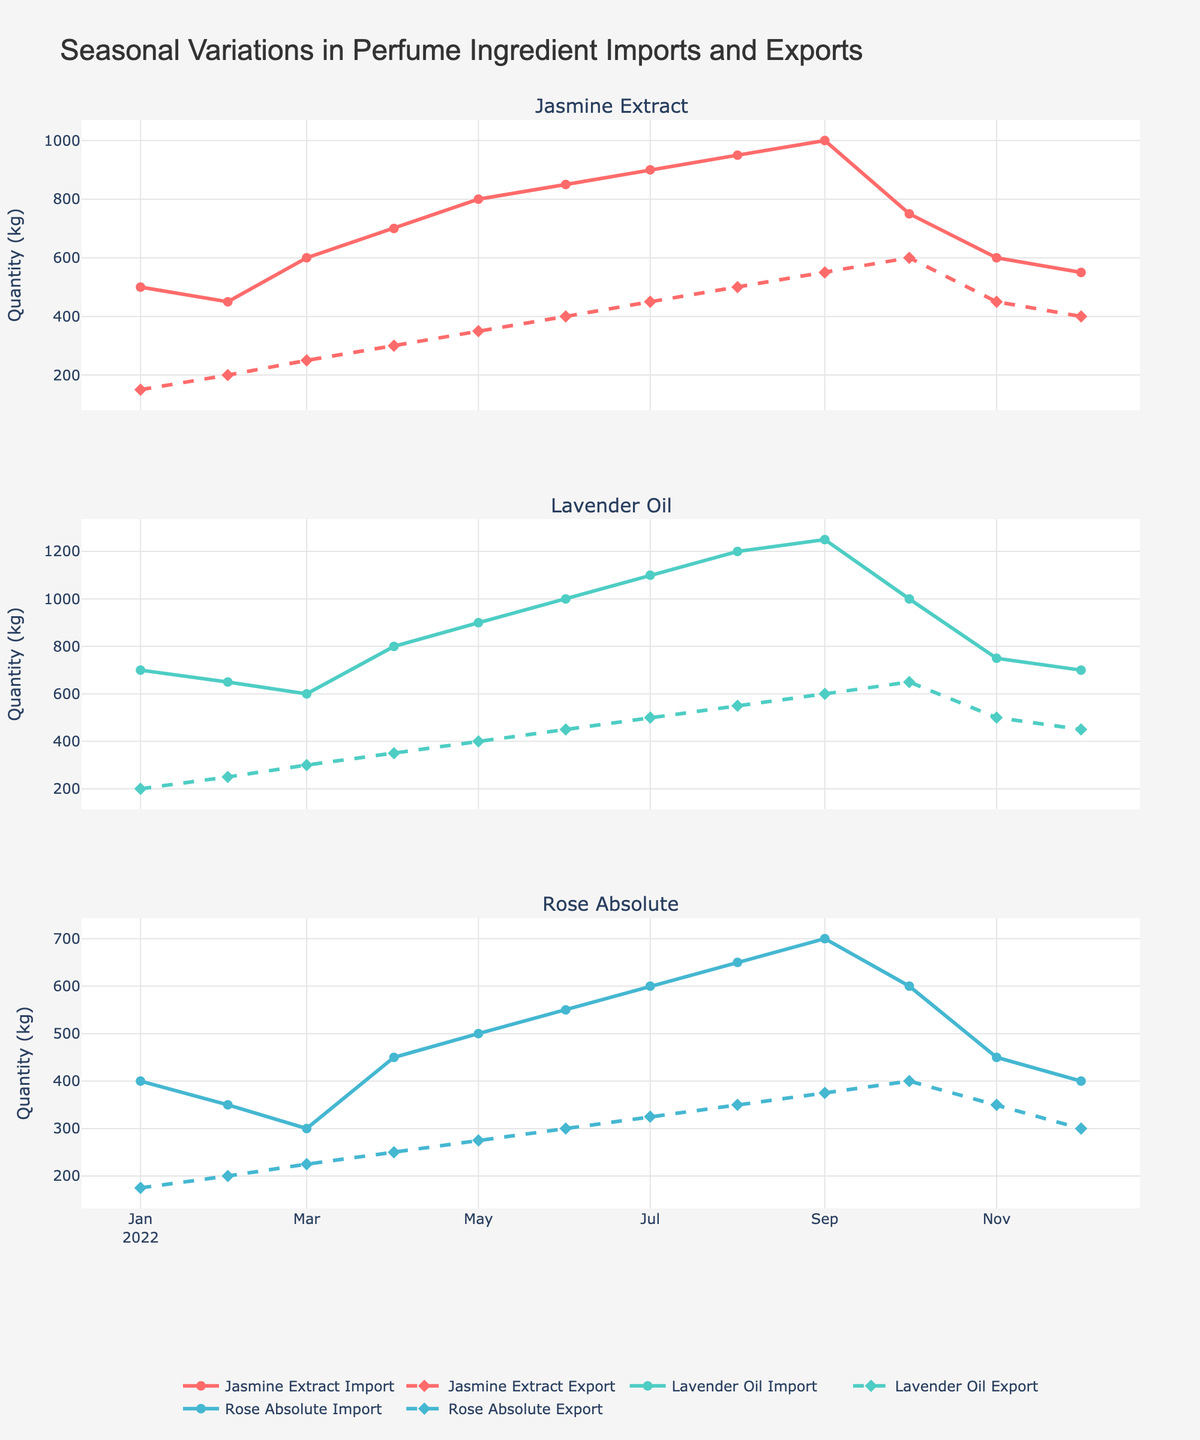What is the title of the figure? The title is located at the top of the figure. By reading it, we can understand the main subject of the plot.
Answer: Seasonal Variations in Perfume Ingredient Imports and Exports How many ingredients are shown in the figure? Each subplot shows data for a different ingredient. Counting the subplot titles will give us the number of ingredients.
Answer: 3 Which ingredient has the highest import quantity in July 2022? Looking at the July data points in each subplot, we check the import quantities for Jasmine Extract, Lavender Oil, and Rose Absolute. The point with the highest value indicates the ingredient with the highest import.
Answer: Lavender Oil During which month did Jasmine Extract have the highest export quantity? By examining the export quantity data points for Jasmine Extract across the months, the highest point indicates the month with the highest export.
Answer: October 2022 What is the overall trend in import quantities for Rose Absolute? Looking at the import quantities for Rose Absolute over the months, we observe the general direction of the data points.
Answer: Increasing trend until September, then decreasing Which month has the largest difference between import and export quantities for Lavender Oil? Calculate the difference between imports and exports for each month for Lavender Oil. The month with the largest absolute difference is the answer.
Answer: January 2022 How do the import and export trends of Jasmine Extract compare? Compare the overall patterns of import and export quantities over the year for Jasmine Extract.
Answer: Both are increasing trends, with exports generally lower than imports During which month do all three ingredients have their peak export quantities? Survey the export quantity data points for all ingredients and identify the common peak month.
Answer: October 2022 What is the average import quantity for Rose Absolute from January to June 2022? Sum the import quantities for Rose Absolute from January to June, then divide by the number of months.
Answer: 4,000/6 = 667 kg Which ingredient shows a consistent increase in both import and export quantities from January to September 2022? Analyze the plots for each ingredient from January to September, checking for consistent increases in both imports and exports.
Answer: Lavender Oil 